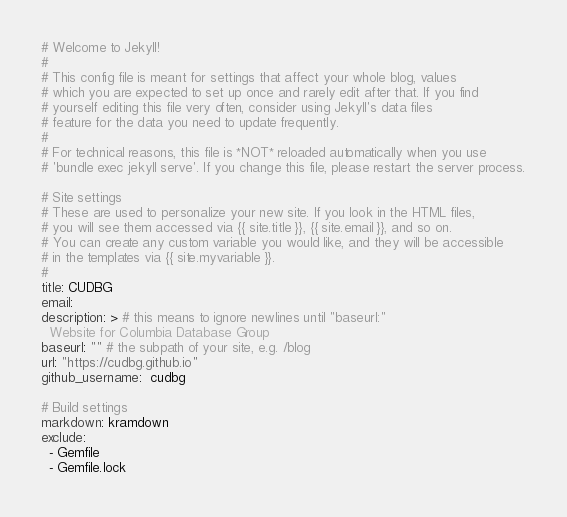<code> <loc_0><loc_0><loc_500><loc_500><_YAML_># Welcome to Jekyll!
#
# This config file is meant for settings that affect your whole blog, values
# which you are expected to set up once and rarely edit after that. If you find
# yourself editing this file very often, consider using Jekyll's data files
# feature for the data you need to update frequently.
#
# For technical reasons, this file is *NOT* reloaded automatically when you use
# 'bundle exec jekyll serve'. If you change this file, please restart the server process.

# Site settings
# These are used to personalize your new site. If you look in the HTML files,
# you will see them accessed via {{ site.title }}, {{ site.email }}, and so on.
# You can create any custom variable you would like, and they will be accessible
# in the templates via {{ site.myvariable }}.
#
title: CUDBG
email: 
description: > # this means to ignore newlines until "baseurl:"
  Website for Columbia Database Group
baseurl: "" # the subpath of your site, e.g. /blog
url: "https://cudbg.github.io" 
github_username:  cudbg

# Build settings
markdown: kramdown
exclude:
  - Gemfile
  - Gemfile.lock
</code> 